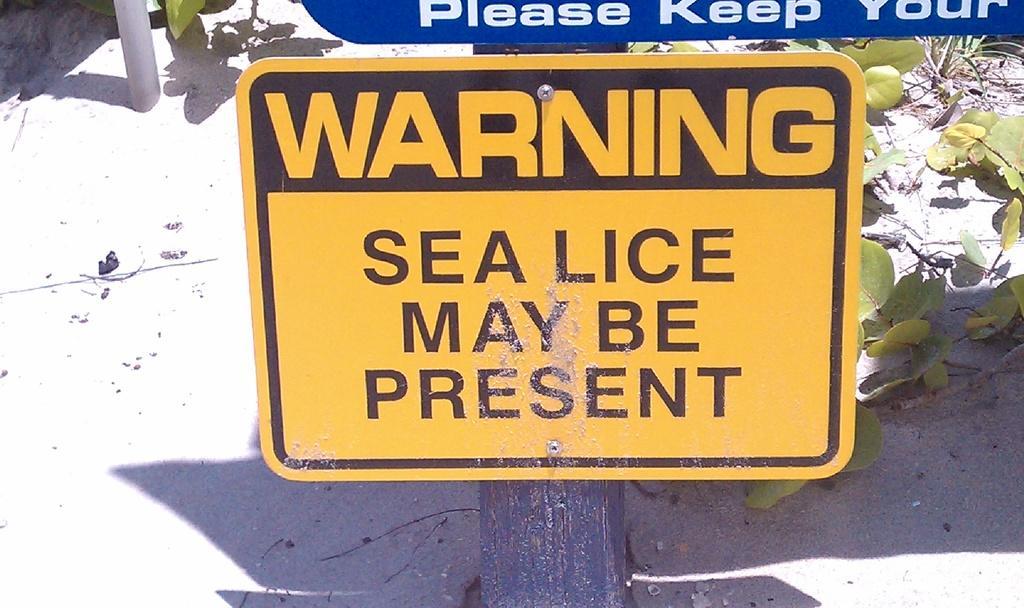Please provide a concise description of this image. In this image I can see there is a warning board on the pole, beside that there is another board and plant on the ground. 